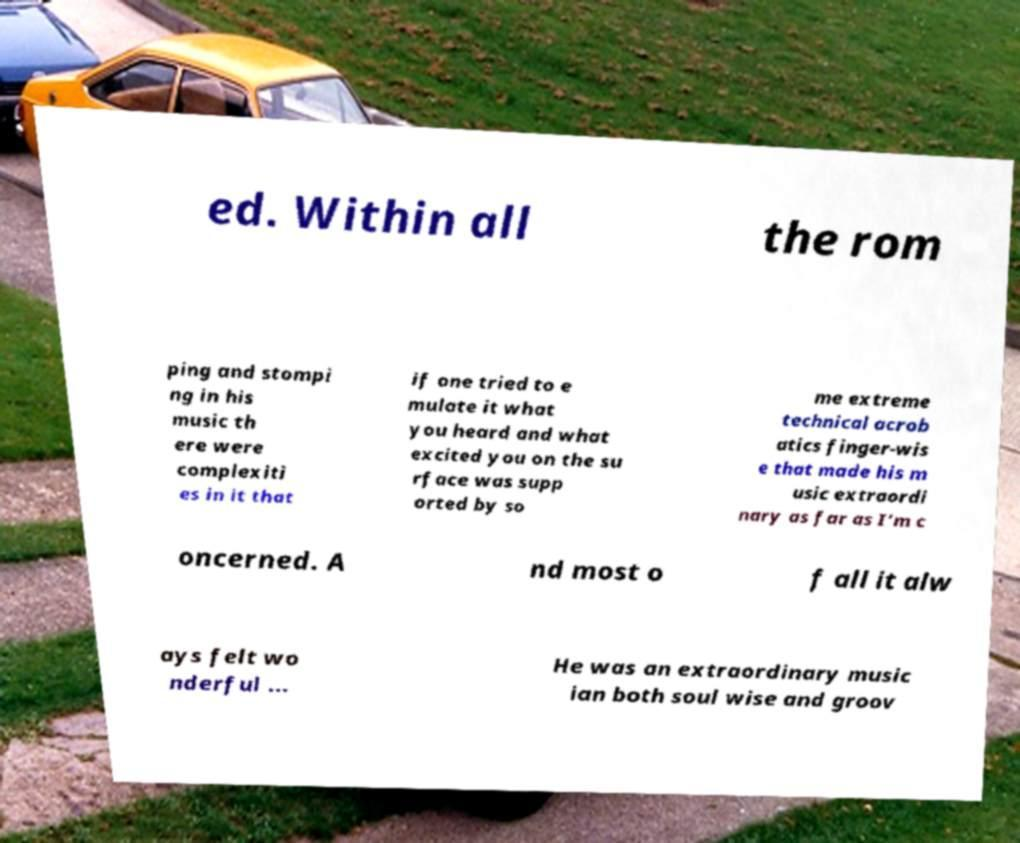Can you accurately transcribe the text from the provided image for me? ed. Within all the rom ping and stompi ng in his music th ere were complexiti es in it that if one tried to e mulate it what you heard and what excited you on the su rface was supp orted by so me extreme technical acrob atics finger-wis e that made his m usic extraordi nary as far as I’m c oncerned. A nd most o f all it alw ays felt wo nderful ... He was an extraordinary music ian both soul wise and groov 